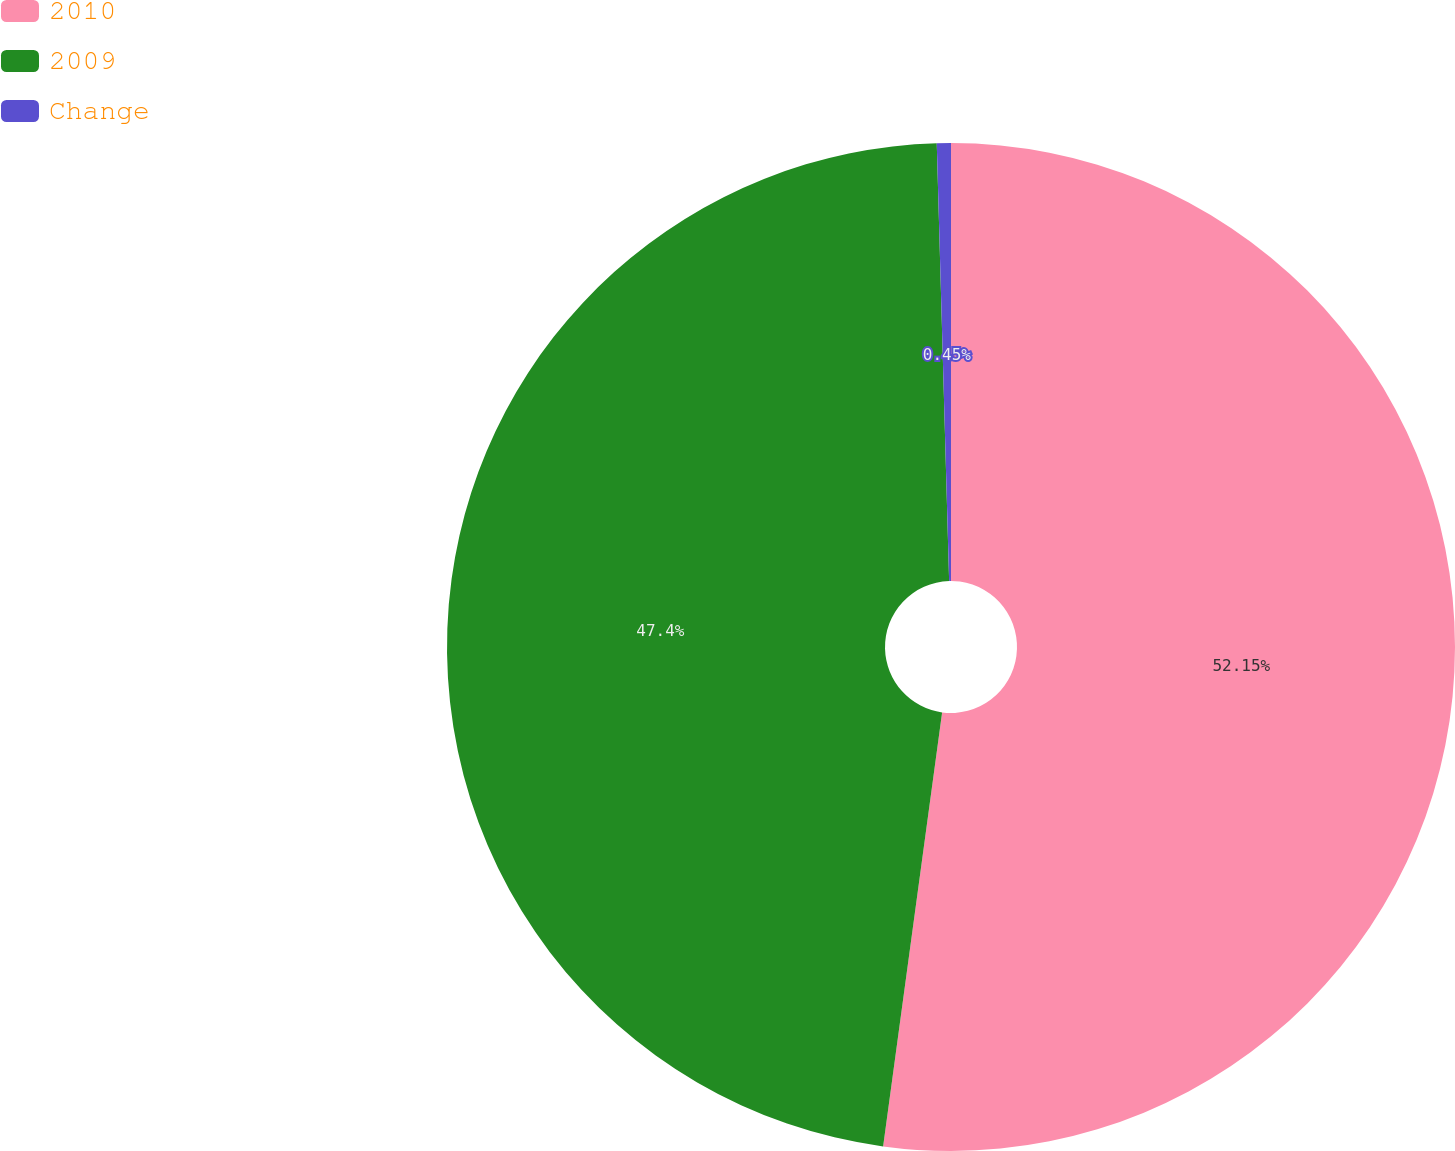Convert chart. <chart><loc_0><loc_0><loc_500><loc_500><pie_chart><fcel>2010<fcel>2009<fcel>Change<nl><fcel>52.15%<fcel>47.4%<fcel>0.45%<nl></chart> 